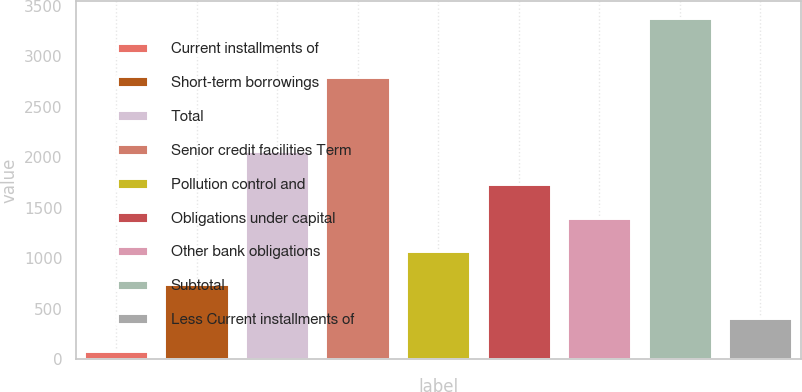Convert chart. <chart><loc_0><loc_0><loc_500><loc_500><bar_chart><fcel>Current installments of<fcel>Short-term borrowings<fcel>Total<fcel>Senior credit facilities Term<fcel>Pollution control and<fcel>Obligations under capital<fcel>Other bank obligations<fcel>Subtotal<fcel>Less Current installments of<nl><fcel>81<fcel>741<fcel>2061<fcel>2794<fcel>1071<fcel>1731<fcel>1401<fcel>3381<fcel>411<nl></chart> 